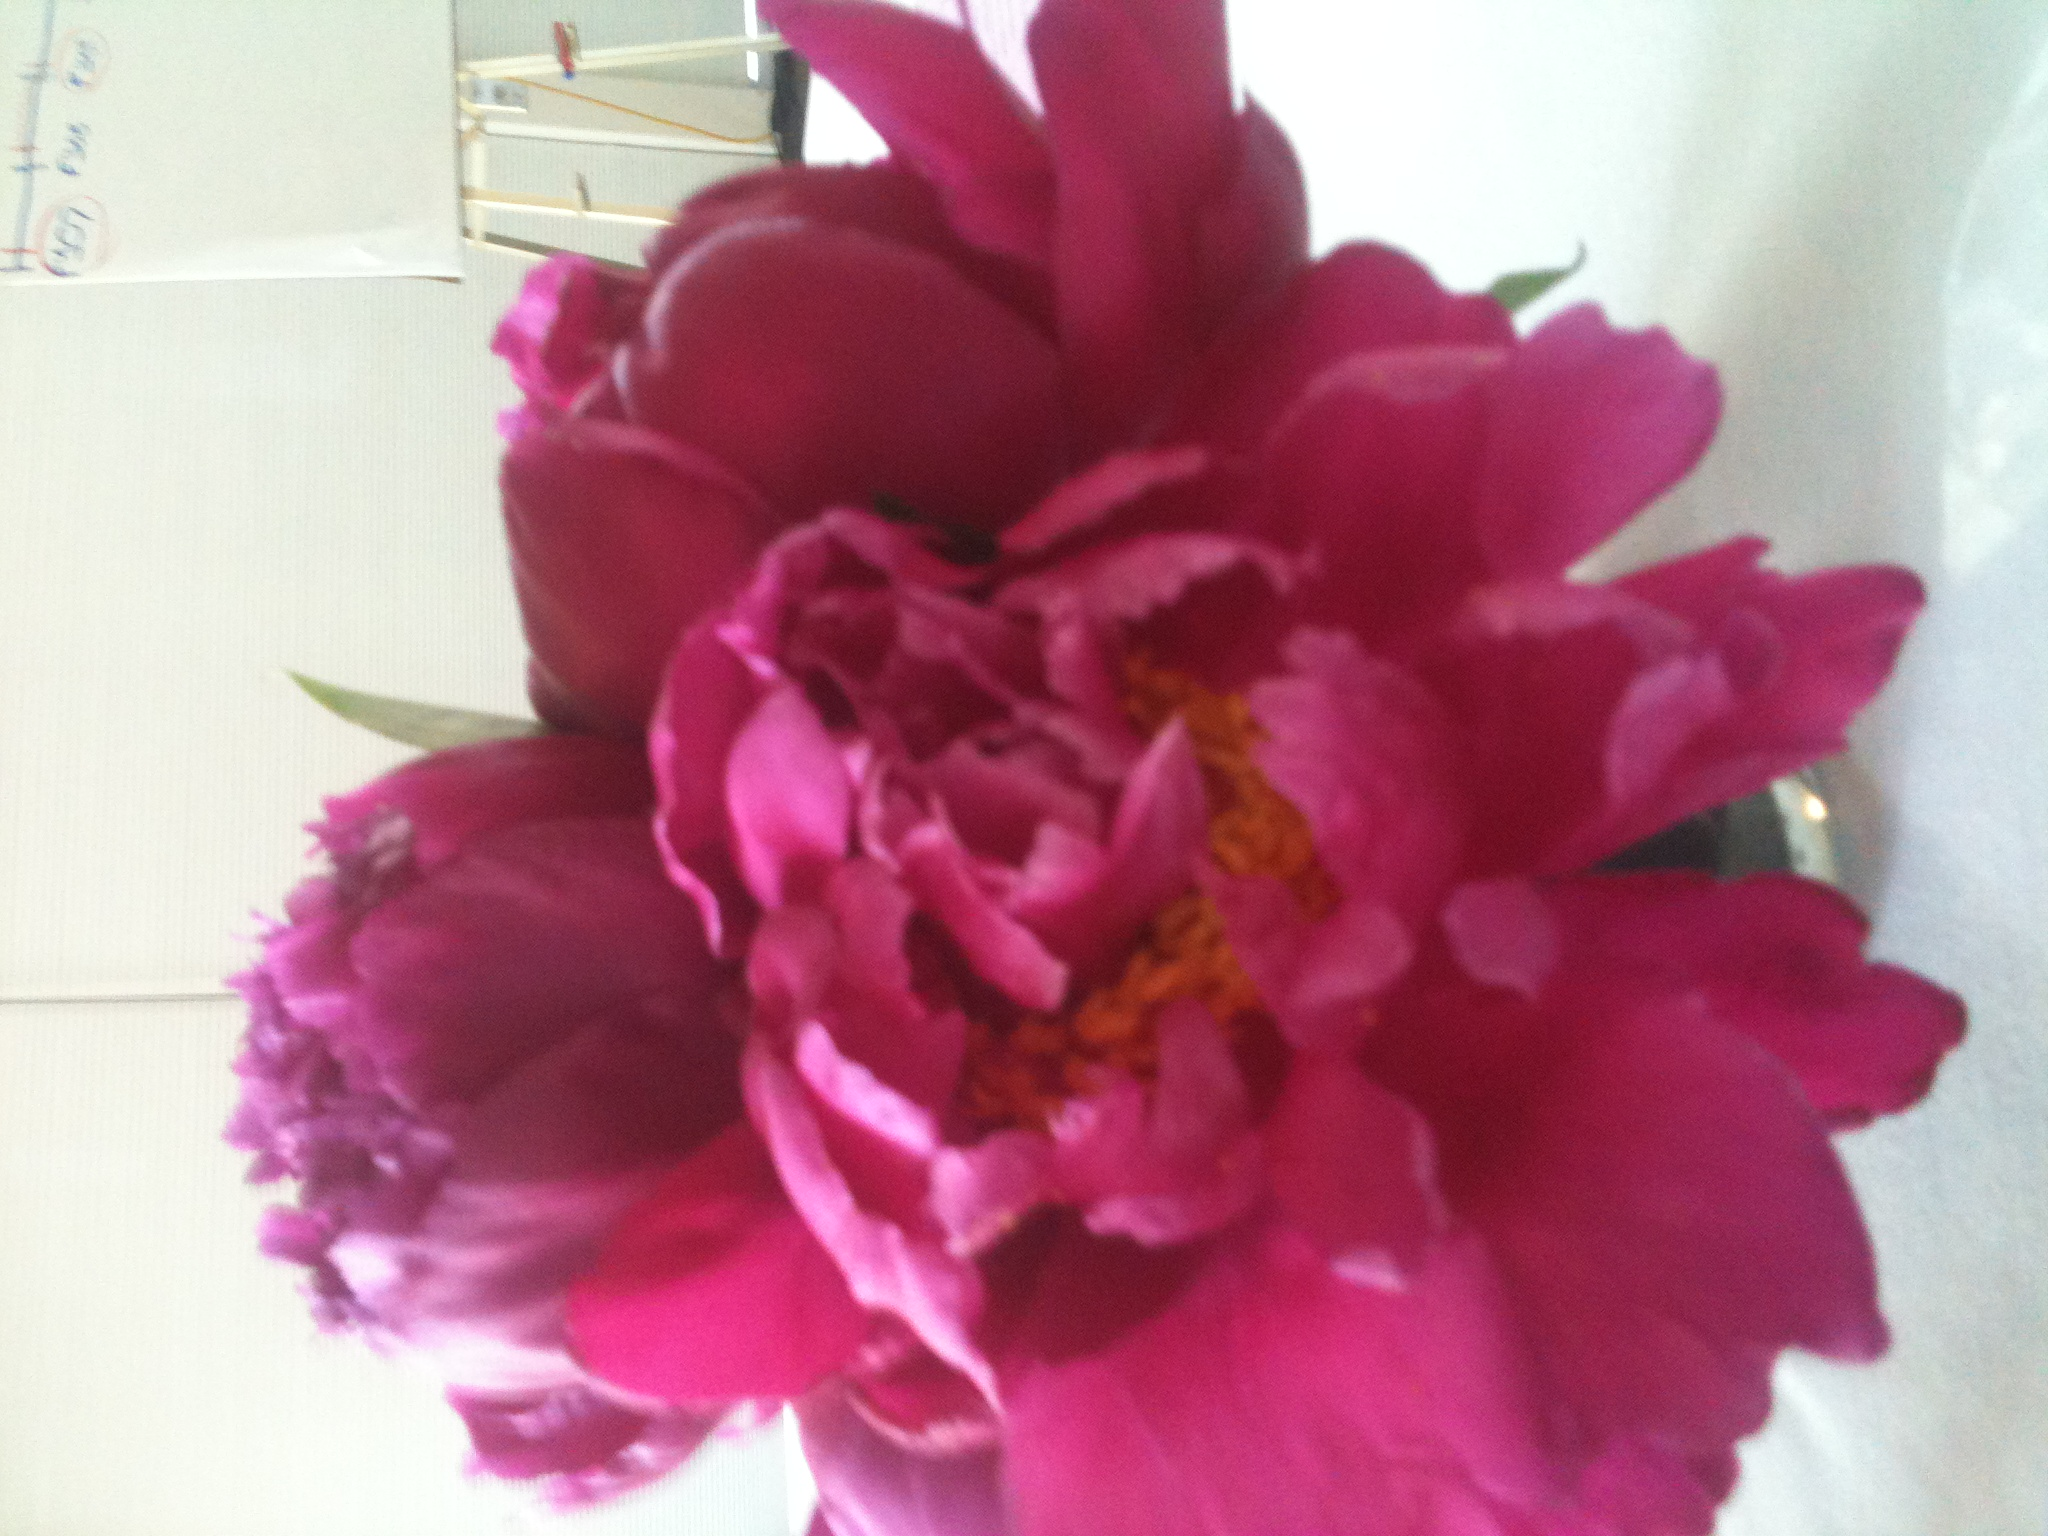what is this? This is a vibrant, richly colored pink flower—specifically, it looks like a type of peony. Peonies are known for their large, lush blooms and pleasant fragrance, often used in floral arrangements and gardens for their beauty and cheerfulness. 